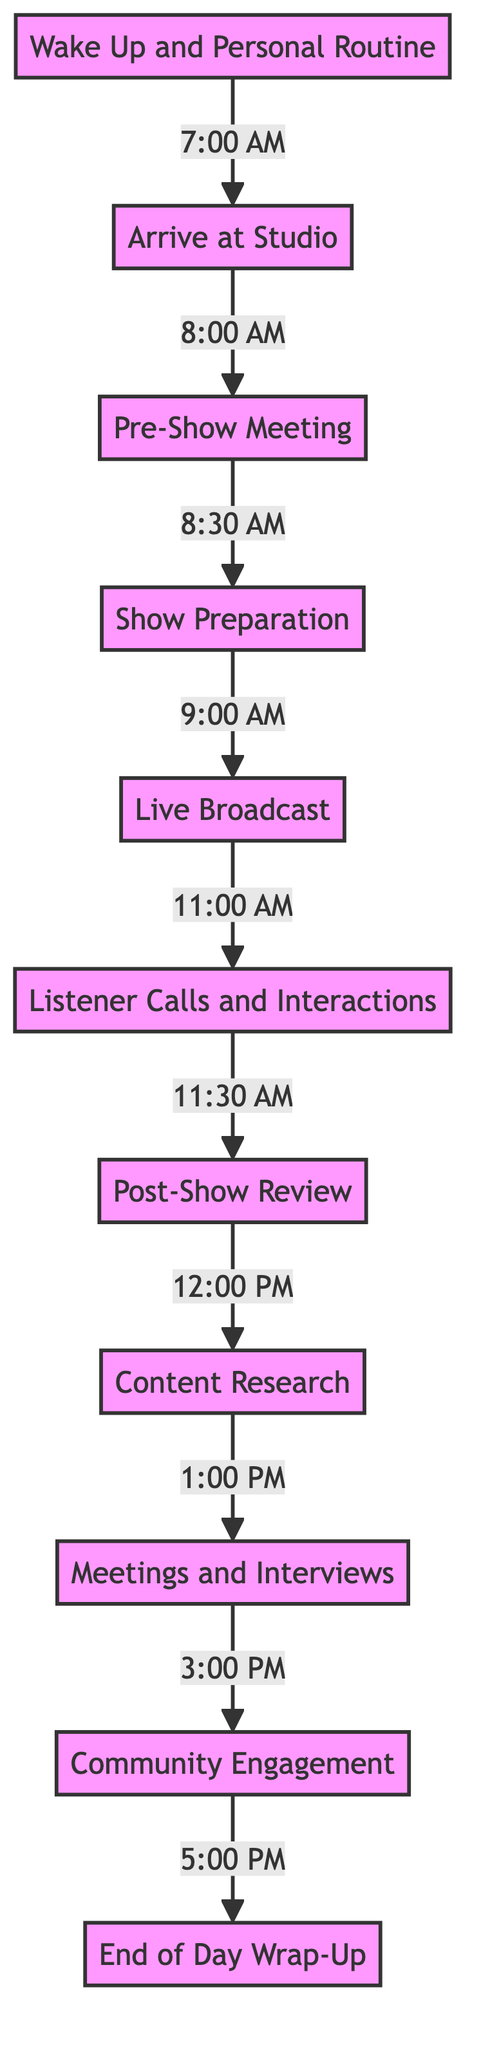What is the first activity listed in the diagram? The diagram starts with the activity at node 1, which is "Wake Up and Personal Routine". This is the initial step before arriving at the studio.
Answer: Wake Up and Personal Routine What time does the live broadcast begin? The live broadcast is indicated at node 5, which connects from show preparation starting at 9:00 AM. The live broadcast specifically starts at 11:00 AM.
Answer: 11:00 AM How long is the show preparation period? The show preparation period is indicated between node 4 and node 5 in the diagram. Show preparation starts at 9:00 AM and is immediately followed by the live broadcast at 11:00 AM, making the duration 2 hours.
Answer: 2 hours What activity follows listener calls and interactions? In the flow of the diagram, listener calls and interactions (node 6) are followed by the post-show review (node 7) which starts at 11:30 AM.
Answer: Post-Show Review How many total activities are listed in the diagram? The diagram contains a total of 11 distinct activities or nodes, ranging from waking up to the end-of-day wrap-up. Counting all activities gives the total number.
Answer: 11 At what time does the community engagement start? Community engagement is detailed at node 10, which is connected to meetings and interviews that begin at 3:00 PM. Hence, community engagement starts immediately after, at 5:00 PM.
Answer: 5:00 PM What is the longest continuous period mentioned in the daily routine? When analyzing the diagram, the longest continuous period without a break is from 9:00 AM, when show preparation starts, to 11:30 AM, following the live broadcast and listener interactions. This is 2 hours 30 minutes long.
Answer: 2 hours 30 minutes Which two activities are scheduled back-to-back immediately? The activities that are back-to-back in the diagram are the live broadcast (node 5) immediately followed by listener calls and interactions (node 6), showing no gap in between them.
Answer: Live Broadcast and Listener Calls and Interactions 